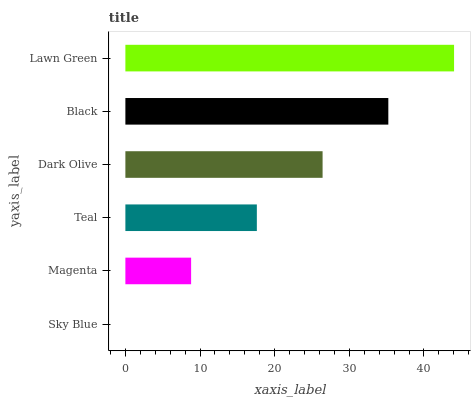Is Sky Blue the minimum?
Answer yes or no. Yes. Is Lawn Green the maximum?
Answer yes or no. Yes. Is Magenta the minimum?
Answer yes or no. No. Is Magenta the maximum?
Answer yes or no. No. Is Magenta greater than Sky Blue?
Answer yes or no. Yes. Is Sky Blue less than Magenta?
Answer yes or no. Yes. Is Sky Blue greater than Magenta?
Answer yes or no. No. Is Magenta less than Sky Blue?
Answer yes or no. No. Is Dark Olive the high median?
Answer yes or no. Yes. Is Teal the low median?
Answer yes or no. Yes. Is Black the high median?
Answer yes or no. No. Is Lawn Green the low median?
Answer yes or no. No. 